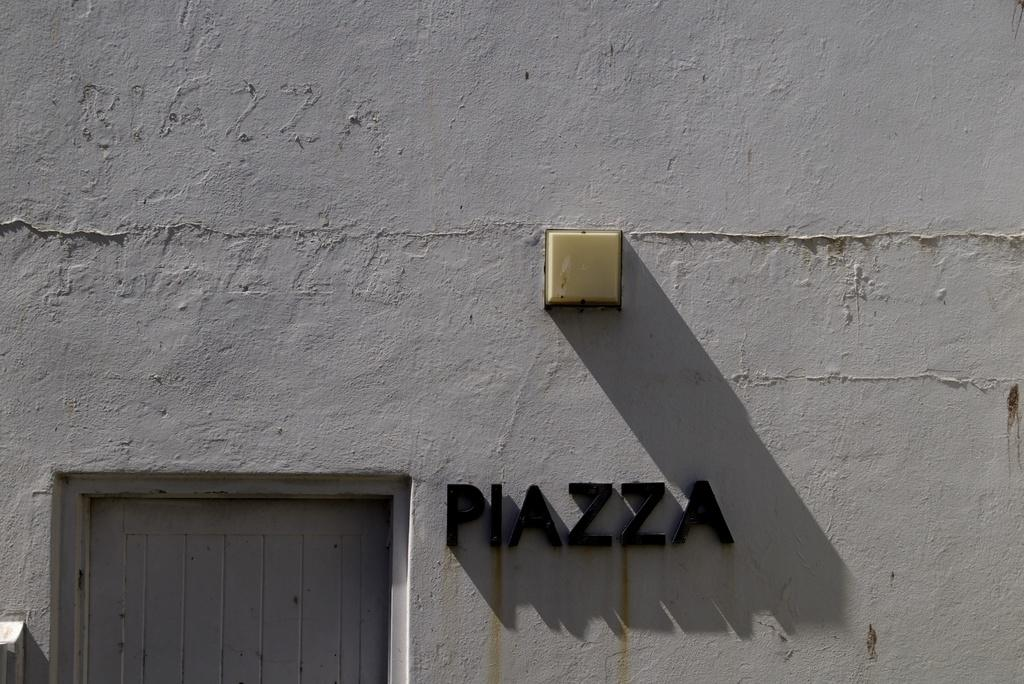Where was the picture taken? The picture was clicked outside. What can be seen in the center of the image? There is text and a door of a building in the center of the image. Can you describe any other objects in the image? There appears to be a wall-mounted lamp in the image. What type of cloth is draped over the door in the image? There is no cloth draped over the door in the image; it is a door of a building with text in the center. 